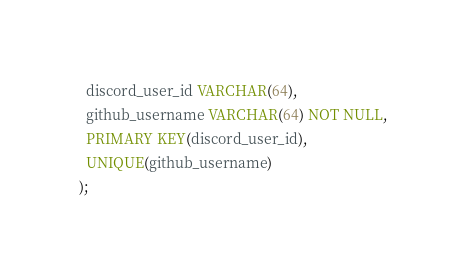<code> <loc_0><loc_0><loc_500><loc_500><_SQL_>  discord_user_id VARCHAR(64),
  github_username VARCHAR(64) NOT NULL,
  PRIMARY KEY(discord_user_id),
  UNIQUE(github_username)
);
</code> 